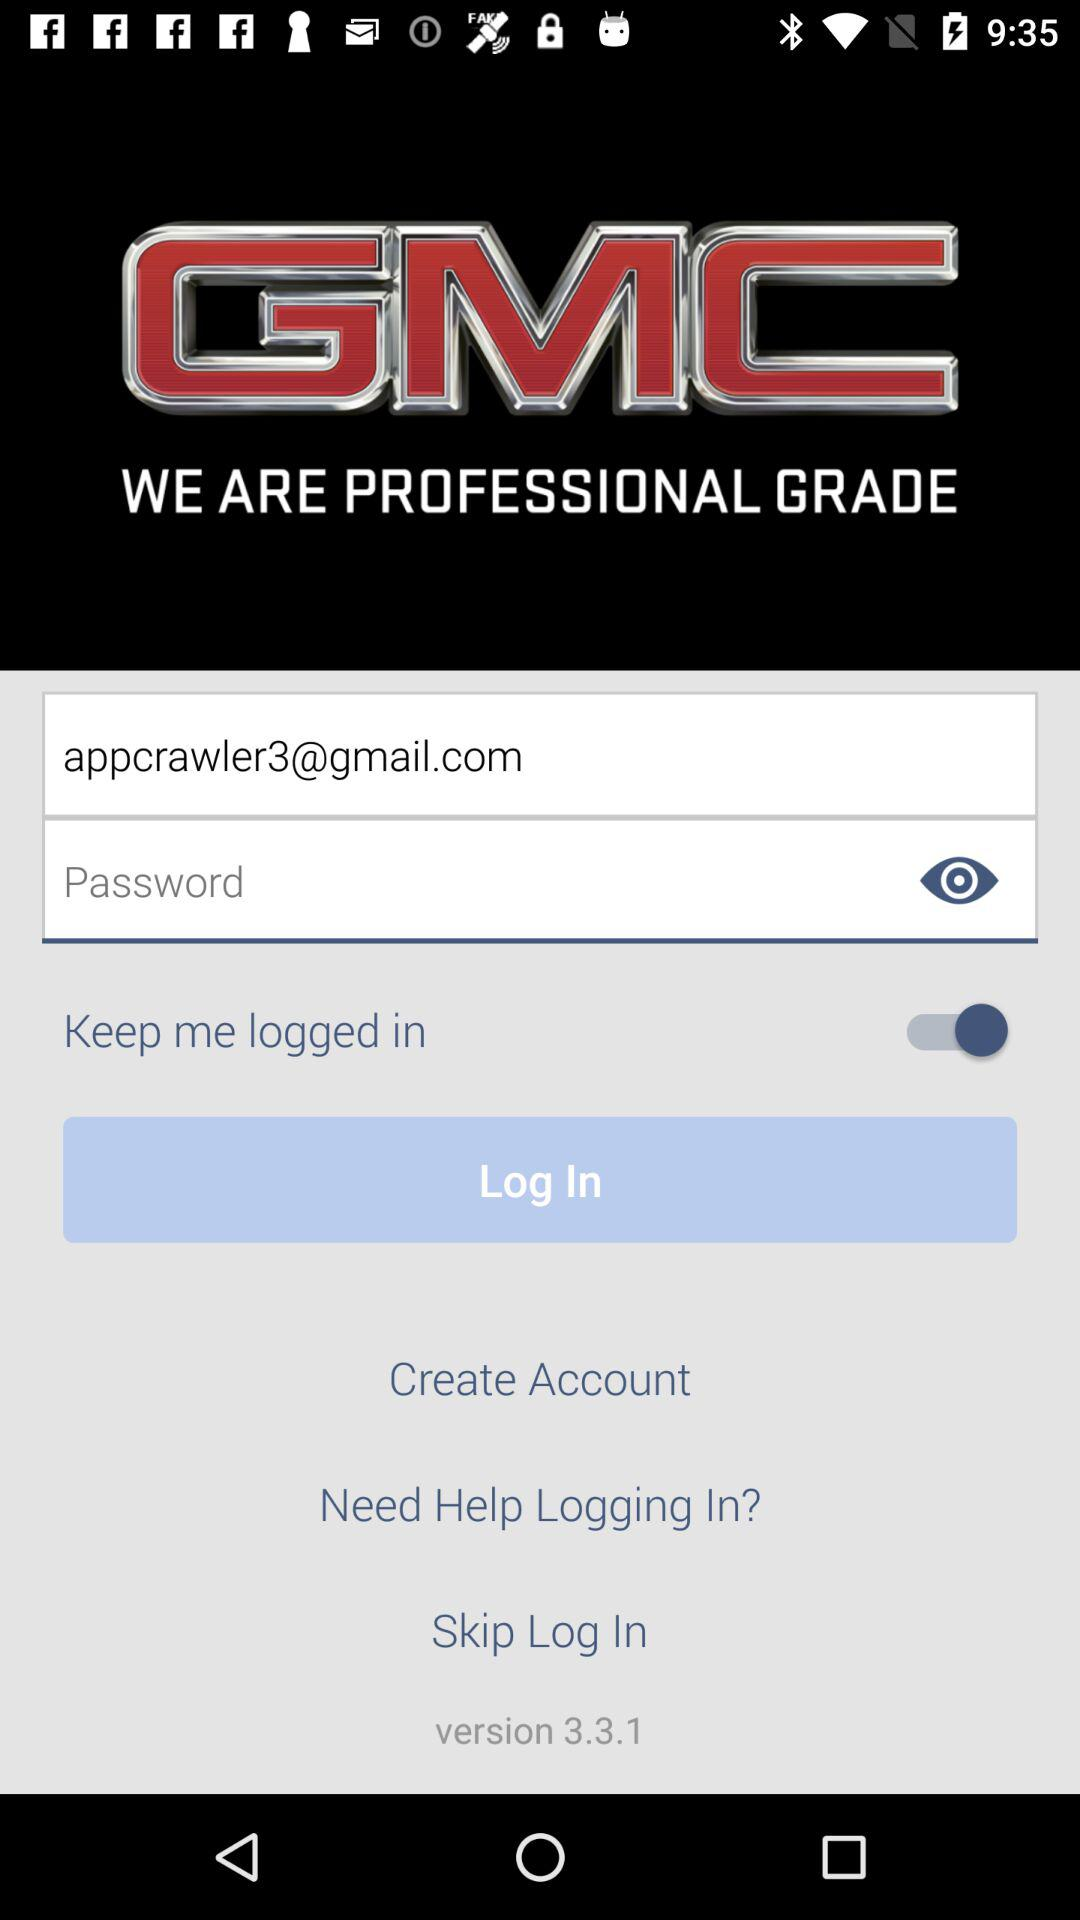What is the version of the application? The version of the application is 3.3.1. 